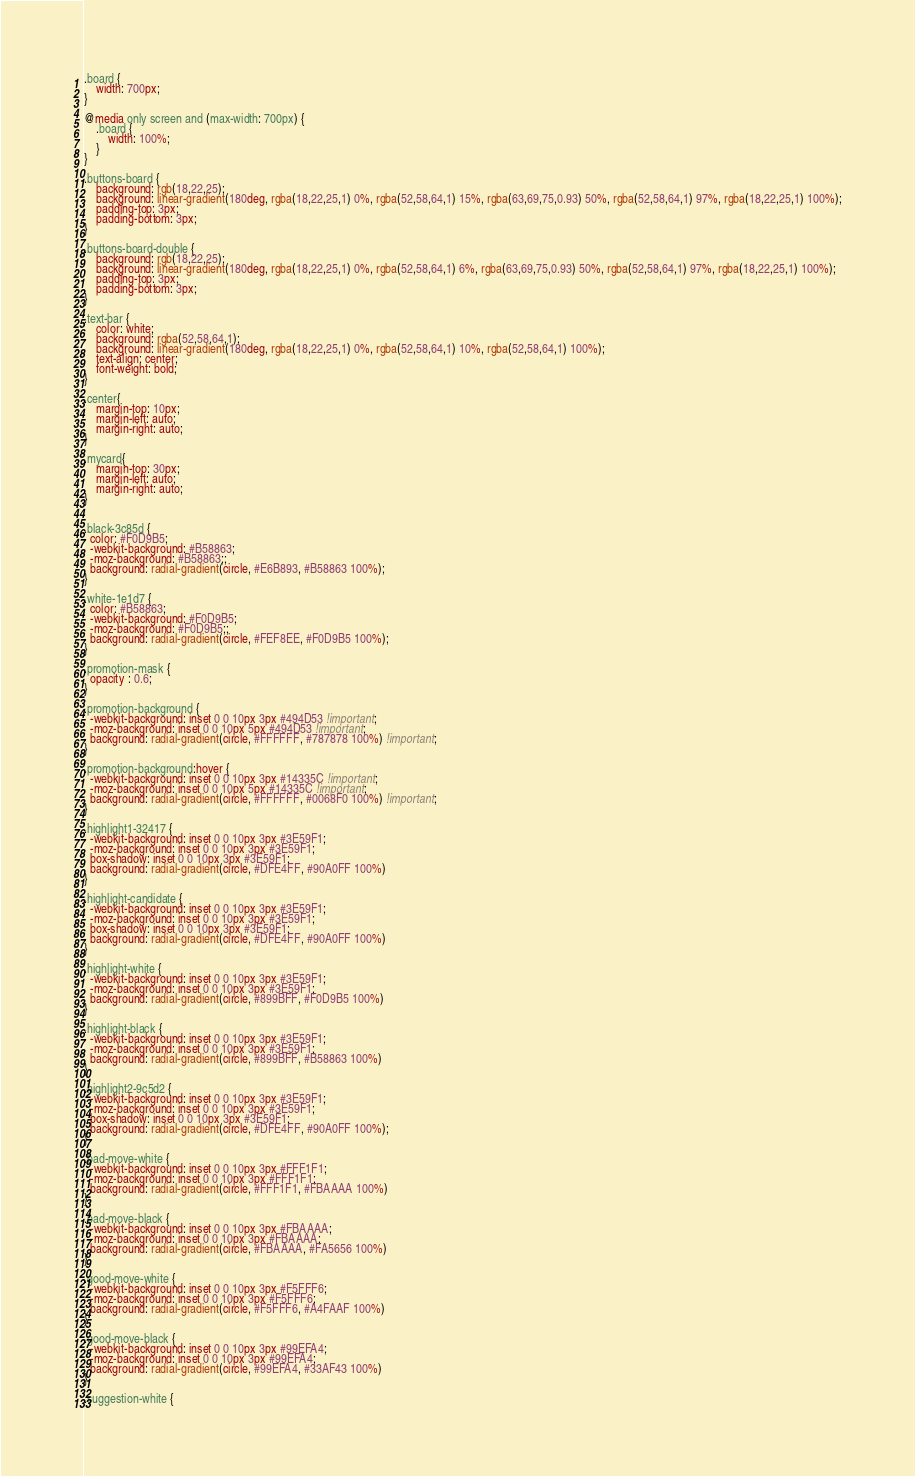<code> <loc_0><loc_0><loc_500><loc_500><_CSS_>.board {
    width: 700px;
}

@media only screen and (max-width: 700px) {
    .board {
        width: 100%;
    }
}

.buttons-board {
    background: rgb(18,22,25);
    background: linear-gradient(180deg, rgba(18,22,25,1) 0%, rgba(52,58,64,1) 15%, rgba(63,69,75,0.93) 50%, rgba(52,58,64,1) 97%, rgba(18,22,25,1) 100%);
    padding-top: 3px;
    padding-bottom: 3px;
}

.buttons-board-double {
    background: rgb(18,22,25);
    background: linear-gradient(180deg, rgba(18,22,25,1) 0%, rgba(52,58,64,1) 6%, rgba(63,69,75,0.93) 50%, rgba(52,58,64,1) 97%, rgba(18,22,25,1) 100%);
    padding-top: 3px;
    padding-bottom: 3px;
}

.text-bar {
    color: white;
    background: rgba(52,58,64,1);
    background: linear-gradient(180deg, rgba(18,22,25,1) 0%, rgba(52,58,64,1) 10%, rgba(52,58,64,1) 100%);
    text-align: center;
    font-weight: bold;
}

.center{
    margin-top: 10px;
    margin-left: auto;
    margin-right: auto;
}

.mycard{
    margin-top: 30px;
    margin-left: auto;
    margin-right: auto;
}


.black-3c85d {
  color: #F0D9B5;
  -webkit-background: #B58863;
  -moz-background: #B58863;;
  background: radial-gradient(circle, #E6B893, #B58863 100%);
}

.white-1e1d7 {
  color: #B58863;
  -webkit-background: #F0D9B5;
  -moz-background: #F0D9B5;;
  background: radial-gradient(circle, #FEF8EE, #F0D9B5 100%);
}

.promotion-mask {
  opacity : 0.6;
}

.promotion-background {
  -webkit-background: inset 0 0 10px 3px #494D53 !important;
  -moz-background: inset 0 0 10px 5px #494D53 !important;
  background: radial-gradient(circle, #FFFFFF, #787878 100%) !important;
}

.promotion-background:hover {
  -webkit-background: inset 0 0 10px 3px #14335C !important;
  -moz-background: inset 0 0 10px 5px #14335C !important;
  background: radial-gradient(circle, #FFFFFF, #0068F0 100%) !important;
}

.highlight1-32417 {
  -webkit-background: inset 0 0 10px 3px #3E59F1;
  -moz-background: inset 0 0 10px 3px #3E59F1;
  box-shadow: inset 0 0 10px 3px #3E59F1;
  background: radial-gradient(circle, #DFE4FF, #90A0FF 100%)
}

.highlight-candidate {
  -webkit-background: inset 0 0 10px 3px #3E59F1;
  -moz-background: inset 0 0 10px 3px #3E59F1;
  box-shadow: inset 0 0 10px 3px #3E59F1;
  background: radial-gradient(circle, #DFE4FF, #90A0FF 100%)
}

.highlight-white {
  -webkit-background: inset 0 0 10px 3px #3E59F1;
  -moz-background: inset 0 0 10px 3px #3E59F1;
  background: radial-gradient(circle, #899BFF, #F0D9B5 100%)
}

.highlight-black {
  -webkit-background: inset 0 0 10px 3px #3E59F1;
  -moz-background: inset 0 0 10px 3px #3E59F1;
  background: radial-gradient(circle, #899BFF, #B58863 100%)
}

.highlight2-9c5d2 {
  -webkit-background: inset 0 0 10px 3px #3E59F1;
  -moz-background: inset 0 0 10px 3px #3E59F1;
  box-shadow: inset 0 0 10px 3px #3E59F1;
  background: radial-gradient(circle, #DFE4FF, #90A0FF 100%);
}

.bad-move-white {
  -webkit-background: inset 0 0 10px 3px #FFF1F1;
  -moz-background: inset 0 0 10px 3px #FFF1F1;
  background: radial-gradient(circle, #FFF1F1, #FBAAAA 100%)
}

.bad-move-black {
  -webkit-background: inset 0 0 10px 3px #FBAAAA;
  -moz-background: inset 0 0 10px 3px #FBAAAA;
  background: radial-gradient(circle, #FBAAAA, #FA5656 100%)
}

.good-move-white {
  -webkit-background: inset 0 0 10px 3px #F5FFF6;
  -moz-background: inset 0 0 10px 3px #F5FFF6;
  background: radial-gradient(circle, #F5FFF6, #A4FAAF 100%)
}

.good-move-black {
  -webkit-background: inset 0 0 10px 3px #99EFA4;
  -moz-background: inset 0 0 10px 3px #99EFA4;
  background: radial-gradient(circle, #99EFA4, #33AF43 100%)
}

.suggestion-white {</code> 